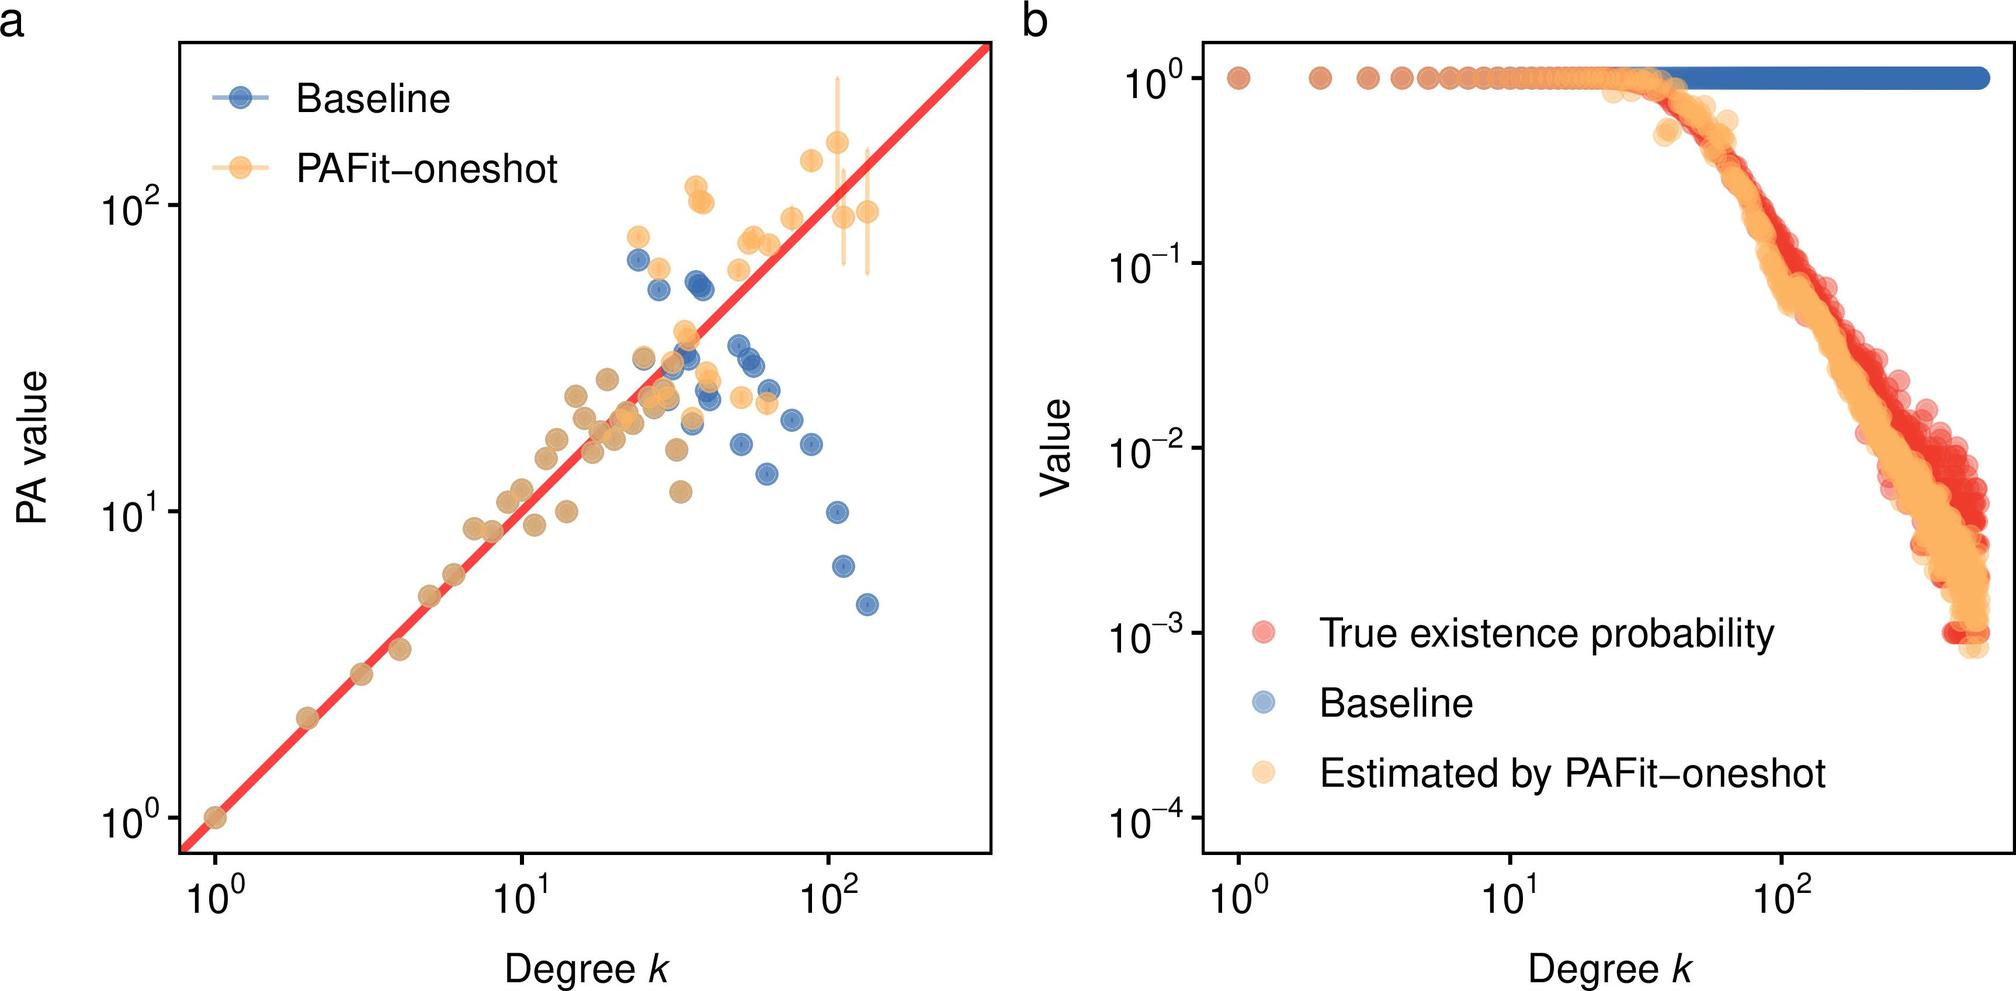Can you explain how the distribution patterns seen in figure b might affect statistical analysis and model validation? The distribution patterns depicted in figure b, showcasing a gradation in data point density, are critical for statistical analysis and model validation. Higher densities indicate areas where the model has more data points to base its estimates on, potentially increasing the confidence in predictions made for these regions. Conversely, areas with sparse data might lead to less reliable estimates, highlighting the need for cautious interpretation or further data collection. Overall, understanding these patterns helps in assessing the model's accuracy and identifying zones where it performs well versus areas where robustness may be lacking. 